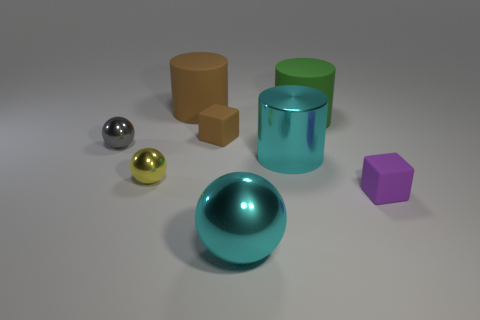Add 1 small purple blocks. How many objects exist? 9 Subtract all cylinders. How many objects are left? 5 Subtract all large cyan things. Subtract all matte things. How many objects are left? 2 Add 4 large brown rubber things. How many large brown rubber things are left? 5 Add 3 tiny gray metallic blocks. How many tiny gray metallic blocks exist? 3 Subtract 0 green blocks. How many objects are left? 8 